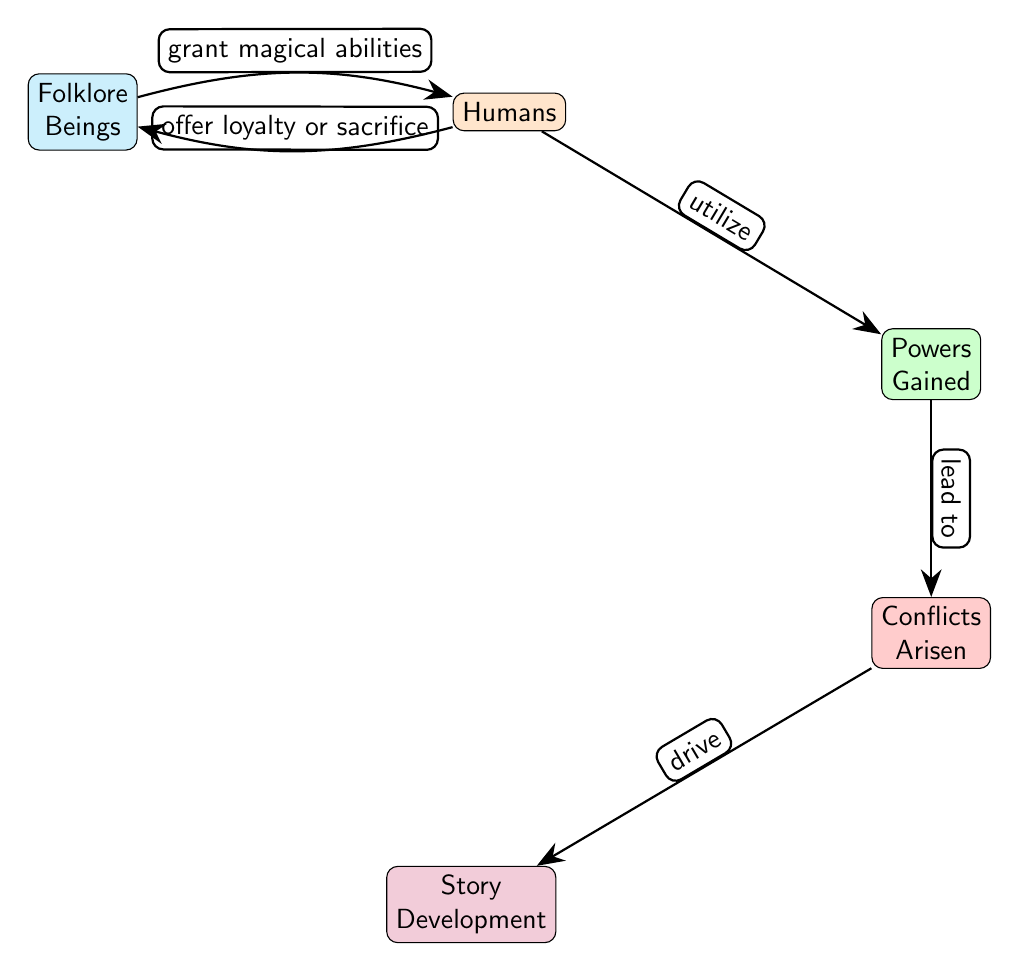What are the two main types of entities depicted in the diagram? The diagram features two main types of entities: "Folklore Beings" and "Humans." These nodes are labeled accordingly, distinguishing their roles within the food chain.
Answer: Folklore Beings, Humans How many nodes are present in the diagram? By counting the nodes, we identify five distinct ones: "Folklore Beings," "Humans," "Powers Gained," "Conflicts Arisen," and "Story Development." This total reflects the various entities involved in the relationships.
Answer: 5 What is the relationship between "Humans" and "Powers Gained"? The diagram indicates that "Humans" have a relationship with "Powers Gained" through the verb "utilize." This shows how humans interact with and make use of the powers that folklore beings could grant them.
Answer: utilize What leads to the "Conflicts Arisen" node? According to the diagram, "Powers Gained" leads to "Conflicts Arisen." This relationship suggests that the acquisition of powers can create disputes or challenges among characters.
Answer: Powers Gained What do "Folklore Beings" grant to "Humans"? The diagram specifies that "Folklore Beings" grant "Humans" "magical abilities," illustrating a direct benefit received by humans from folklore entities.
Answer: magical abilities What drives "Story Development"? The diagram illustrates that "Conflicts Arisen" drive "Story Development." This indicates that the conflicts stemming from powers gained contribute to the progression of the narrative or story in the film.
Answer: Conflicts Arisen What do "Humans" offer in return to "Folklore Beings"? According to the diagram, "Humans" offer "loyalty or sacrifice" to "Folklore Beings." This reveals the reciprocal nature of their relationship, where humans give something significant back.
Answer: loyalty or sacrifice What type of relationship is noted between "Folklore Beings" and "Humans"? The relationship is characterized as a "grant magical abilities" interaction. This type indicates a one-way benefit flowing from the folklore beings to the humans.
Answer: grant magical abilities 